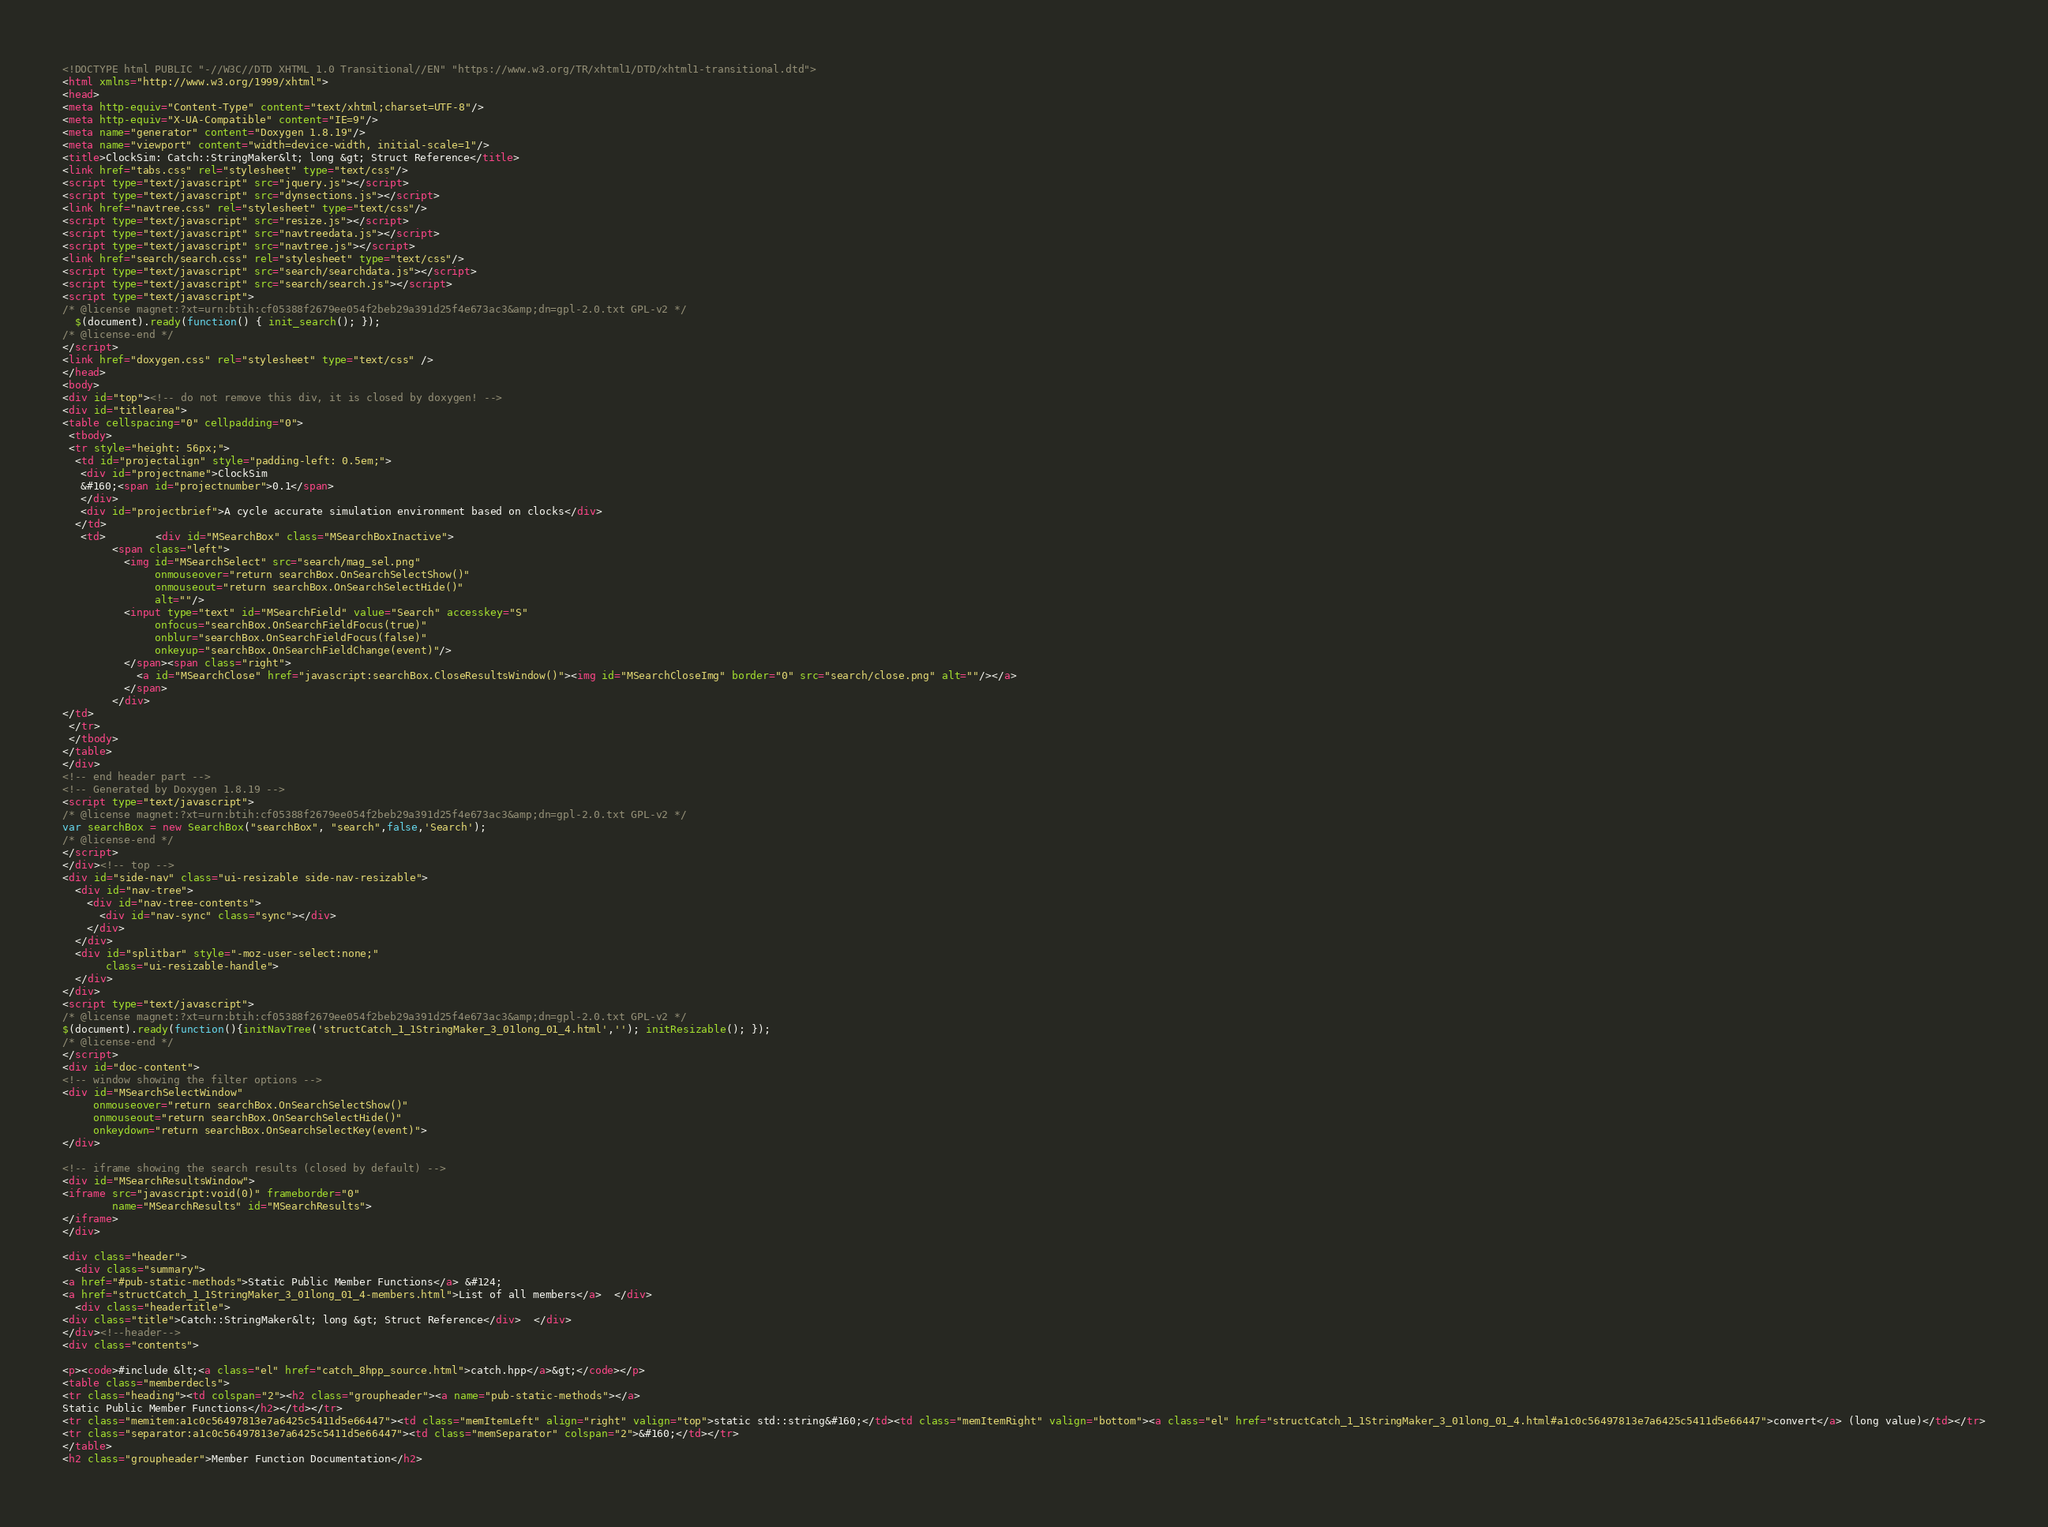<code> <loc_0><loc_0><loc_500><loc_500><_HTML_><!DOCTYPE html PUBLIC "-//W3C//DTD XHTML 1.0 Transitional//EN" "https://www.w3.org/TR/xhtml1/DTD/xhtml1-transitional.dtd">
<html xmlns="http://www.w3.org/1999/xhtml">
<head>
<meta http-equiv="Content-Type" content="text/xhtml;charset=UTF-8"/>
<meta http-equiv="X-UA-Compatible" content="IE=9"/>
<meta name="generator" content="Doxygen 1.8.19"/>
<meta name="viewport" content="width=device-width, initial-scale=1"/>
<title>ClockSim: Catch::StringMaker&lt; long &gt; Struct Reference</title>
<link href="tabs.css" rel="stylesheet" type="text/css"/>
<script type="text/javascript" src="jquery.js"></script>
<script type="text/javascript" src="dynsections.js"></script>
<link href="navtree.css" rel="stylesheet" type="text/css"/>
<script type="text/javascript" src="resize.js"></script>
<script type="text/javascript" src="navtreedata.js"></script>
<script type="text/javascript" src="navtree.js"></script>
<link href="search/search.css" rel="stylesheet" type="text/css"/>
<script type="text/javascript" src="search/searchdata.js"></script>
<script type="text/javascript" src="search/search.js"></script>
<script type="text/javascript">
/* @license magnet:?xt=urn:btih:cf05388f2679ee054f2beb29a391d25f4e673ac3&amp;dn=gpl-2.0.txt GPL-v2 */
  $(document).ready(function() { init_search(); });
/* @license-end */
</script>
<link href="doxygen.css" rel="stylesheet" type="text/css" />
</head>
<body>
<div id="top"><!-- do not remove this div, it is closed by doxygen! -->
<div id="titlearea">
<table cellspacing="0" cellpadding="0">
 <tbody>
 <tr style="height: 56px;">
  <td id="projectalign" style="padding-left: 0.5em;">
   <div id="projectname">ClockSim
   &#160;<span id="projectnumber">0.1</span>
   </div>
   <div id="projectbrief">A cycle accurate simulation environment based on clocks</div>
  </td>
   <td>        <div id="MSearchBox" class="MSearchBoxInactive">
        <span class="left">
          <img id="MSearchSelect" src="search/mag_sel.png"
               onmouseover="return searchBox.OnSearchSelectShow()"
               onmouseout="return searchBox.OnSearchSelectHide()"
               alt=""/>
          <input type="text" id="MSearchField" value="Search" accesskey="S"
               onfocus="searchBox.OnSearchFieldFocus(true)" 
               onblur="searchBox.OnSearchFieldFocus(false)" 
               onkeyup="searchBox.OnSearchFieldChange(event)"/>
          </span><span class="right">
            <a id="MSearchClose" href="javascript:searchBox.CloseResultsWindow()"><img id="MSearchCloseImg" border="0" src="search/close.png" alt=""/></a>
          </span>
        </div>
</td>
 </tr>
 </tbody>
</table>
</div>
<!-- end header part -->
<!-- Generated by Doxygen 1.8.19 -->
<script type="text/javascript">
/* @license magnet:?xt=urn:btih:cf05388f2679ee054f2beb29a391d25f4e673ac3&amp;dn=gpl-2.0.txt GPL-v2 */
var searchBox = new SearchBox("searchBox", "search",false,'Search');
/* @license-end */
</script>
</div><!-- top -->
<div id="side-nav" class="ui-resizable side-nav-resizable">
  <div id="nav-tree">
    <div id="nav-tree-contents">
      <div id="nav-sync" class="sync"></div>
    </div>
  </div>
  <div id="splitbar" style="-moz-user-select:none;" 
       class="ui-resizable-handle">
  </div>
</div>
<script type="text/javascript">
/* @license magnet:?xt=urn:btih:cf05388f2679ee054f2beb29a391d25f4e673ac3&amp;dn=gpl-2.0.txt GPL-v2 */
$(document).ready(function(){initNavTree('structCatch_1_1StringMaker_3_01long_01_4.html',''); initResizable(); });
/* @license-end */
</script>
<div id="doc-content">
<!-- window showing the filter options -->
<div id="MSearchSelectWindow"
     onmouseover="return searchBox.OnSearchSelectShow()"
     onmouseout="return searchBox.OnSearchSelectHide()"
     onkeydown="return searchBox.OnSearchSelectKey(event)">
</div>

<!-- iframe showing the search results (closed by default) -->
<div id="MSearchResultsWindow">
<iframe src="javascript:void(0)" frameborder="0" 
        name="MSearchResults" id="MSearchResults">
</iframe>
</div>

<div class="header">
  <div class="summary">
<a href="#pub-static-methods">Static Public Member Functions</a> &#124;
<a href="structCatch_1_1StringMaker_3_01long_01_4-members.html">List of all members</a>  </div>
  <div class="headertitle">
<div class="title">Catch::StringMaker&lt; long &gt; Struct Reference</div>  </div>
</div><!--header-->
<div class="contents">

<p><code>#include &lt;<a class="el" href="catch_8hpp_source.html">catch.hpp</a>&gt;</code></p>
<table class="memberdecls">
<tr class="heading"><td colspan="2"><h2 class="groupheader"><a name="pub-static-methods"></a>
Static Public Member Functions</h2></td></tr>
<tr class="memitem:a1c0c56497813e7a6425c5411d5e66447"><td class="memItemLeft" align="right" valign="top">static std::string&#160;</td><td class="memItemRight" valign="bottom"><a class="el" href="structCatch_1_1StringMaker_3_01long_01_4.html#a1c0c56497813e7a6425c5411d5e66447">convert</a> (long value)</td></tr>
<tr class="separator:a1c0c56497813e7a6425c5411d5e66447"><td class="memSeparator" colspan="2">&#160;</td></tr>
</table>
<h2 class="groupheader">Member Function Documentation</h2></code> 